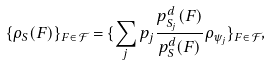Convert formula to latex. <formula><loc_0><loc_0><loc_500><loc_500>\{ \rho _ { S } ( F ) \} _ { F \in { \mathcal { F } } } = \{ \sum _ { j } p _ { j } \frac { p _ { S _ { j } } ^ { d } ( F ) } { p _ { S } ^ { d } ( F ) } \rho _ { \psi _ { j } } \} _ { F \in { \mathcal { F } } } ,</formula> 